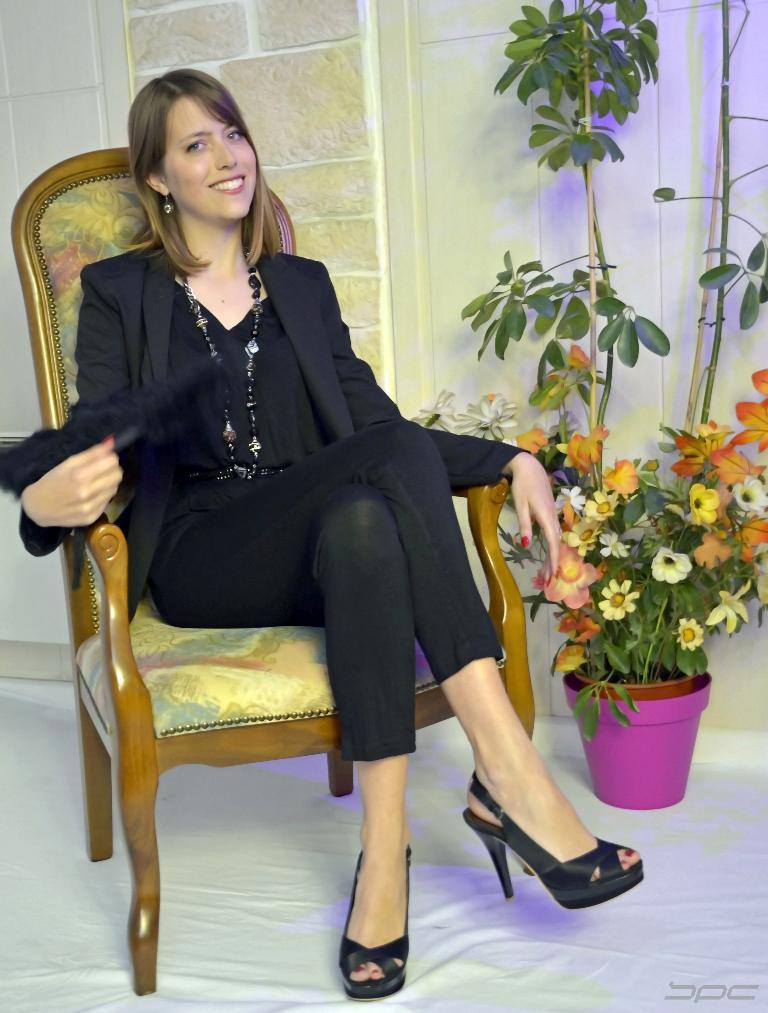What is the woman in the image doing? The woman is sitting on a chair in the image. What is the woman's facial expression in the image? The woman is smiling in the image. What can be seen behind the woman in the image? There is a wall behind the woman in the image. What type of vegetation is present in the image? There is a plant in the bottom right side of the image. What type of payment is the woman receiving in the image? There is no indication of payment in the image; it only shows a woman sitting on a chair and smiling. 